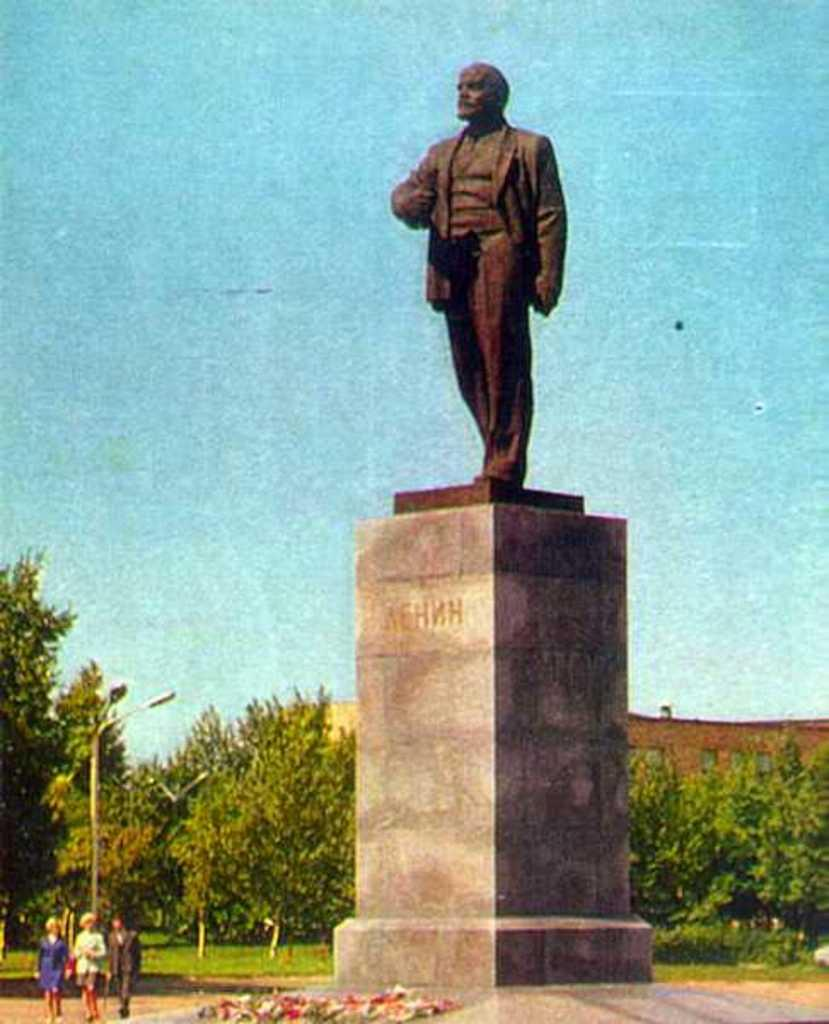What are the people in the image doing? The people in the image are walking. What can be seen on a raised platform in the image? There is a sculpture on a platform in the image. What type of vegetation is present in the image? There is grass in the image. What type of illumination is present in the image? There are lights in the image. What type of structure is present in the image? There is a pole in the image. What type of natural elements are present in the image? There are trees in the image. What can be seen in the background of the image? There is a wall, windows, and the sky visible in the background of the image. How many rings are visible on the trees in the image? There are no rings visible on the trees in the image. What type of root is present in the image? There is no root present in the image. 